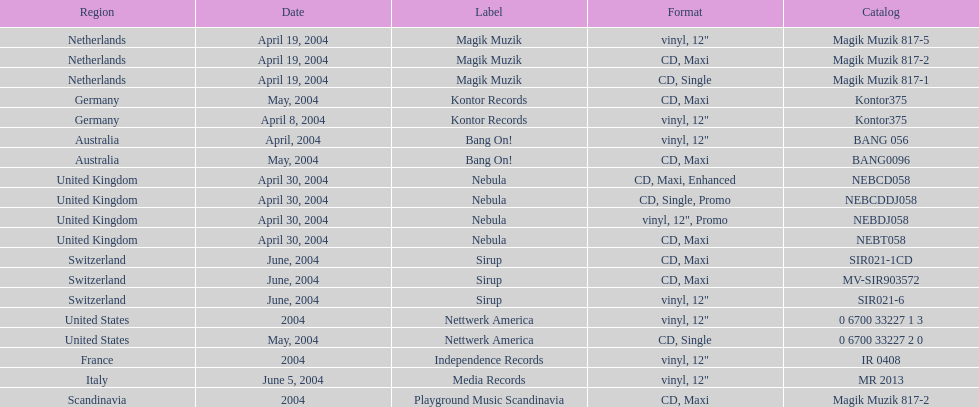What blueprint did france adopt? Vinyl, 12". 